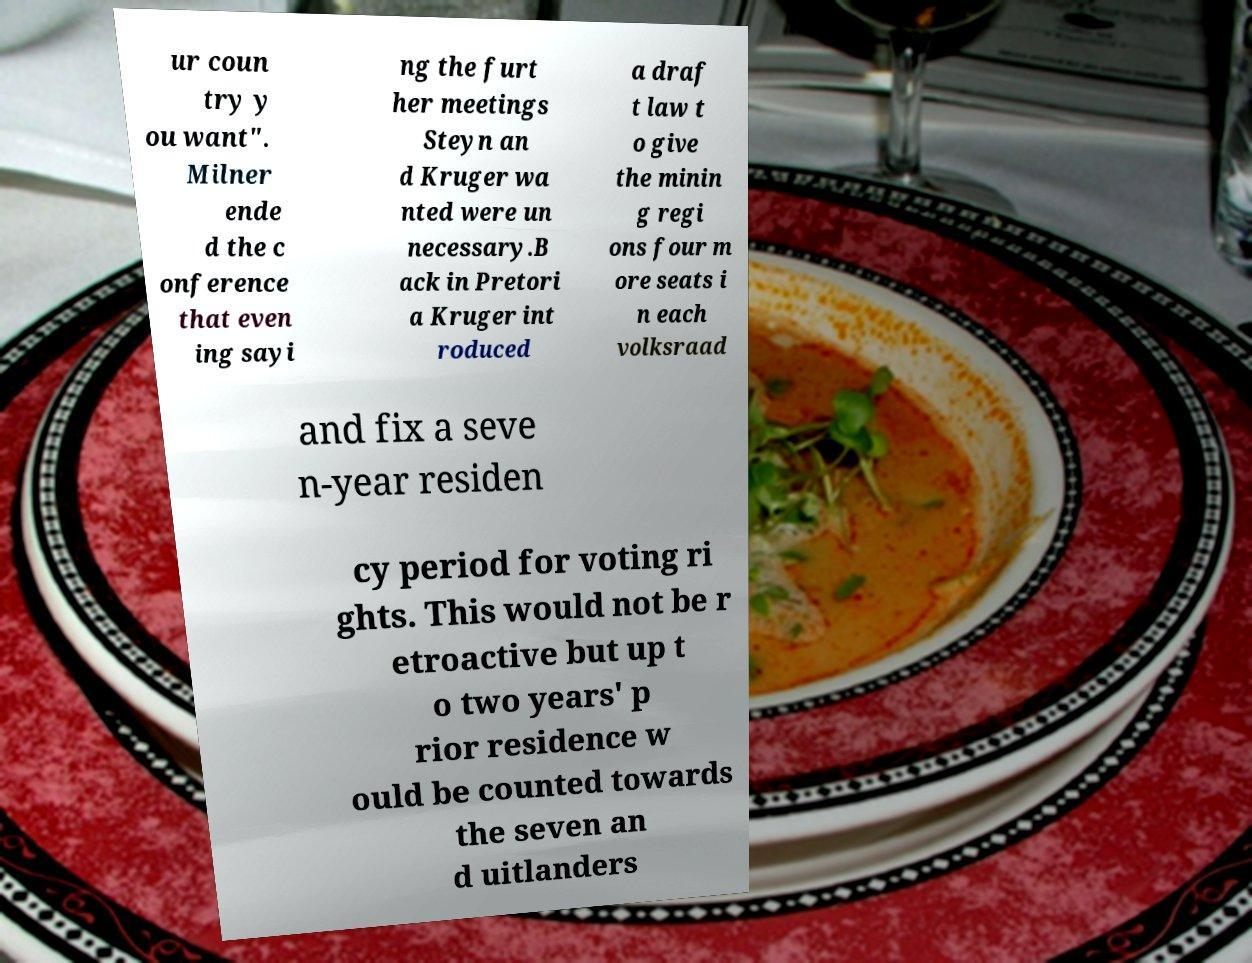I need the written content from this picture converted into text. Can you do that? ur coun try y ou want". Milner ende d the c onference that even ing sayi ng the furt her meetings Steyn an d Kruger wa nted were un necessary.B ack in Pretori a Kruger int roduced a draf t law t o give the minin g regi ons four m ore seats i n each volksraad and fix a seve n-year residen cy period for voting ri ghts. This would not be r etroactive but up t o two years' p rior residence w ould be counted towards the seven an d uitlanders 